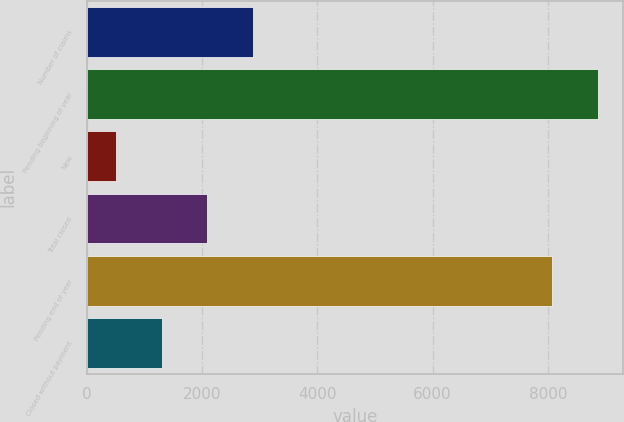<chart> <loc_0><loc_0><loc_500><loc_500><bar_chart><fcel>Number of claims<fcel>Pending beginning of year<fcel>New<fcel>Total closed<fcel>Pending end of year<fcel>Closed without payment<nl><fcel>2881.2<fcel>8863.4<fcel>507<fcel>2089.8<fcel>8072<fcel>1298.4<nl></chart> 